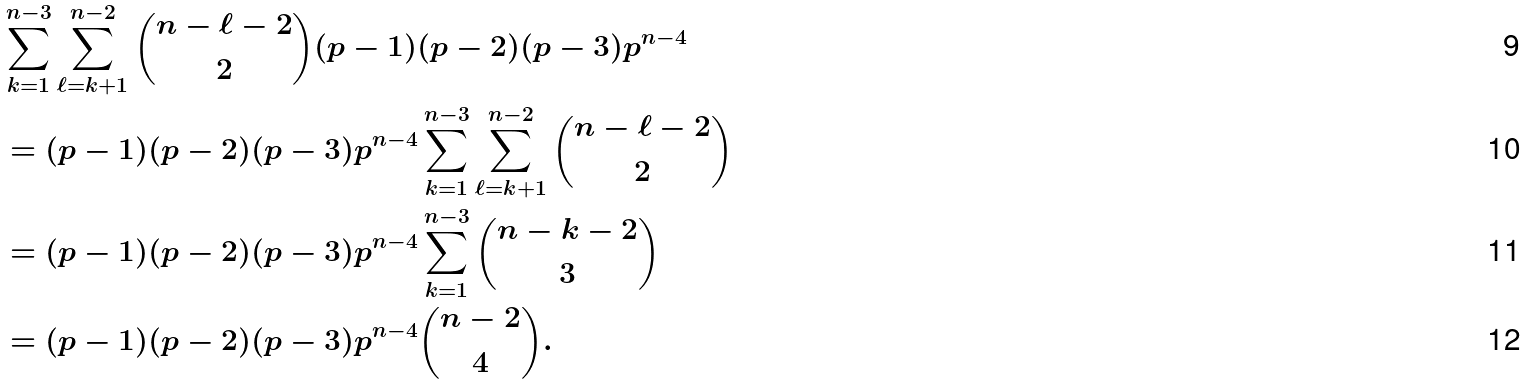Convert formula to latex. <formula><loc_0><loc_0><loc_500><loc_500>& \sum _ { k = 1 } ^ { n - 3 } \sum _ { \ell = k + 1 } ^ { n - 2 } \binom { n - \ell - 2 } { 2 } ( p - 1 ) ( p - 2 ) ( p - 3 ) p ^ { n - 4 } \\ & = ( p - 1 ) ( p - 2 ) ( p - 3 ) p ^ { n - 4 } \sum _ { k = 1 } ^ { n - 3 } \sum _ { \ell = k + 1 } ^ { n - 2 } \binom { n - \ell - 2 } { 2 } \\ & = ( p - 1 ) ( p - 2 ) ( p - 3 ) p ^ { n - 4 } \sum _ { k = 1 } ^ { n - 3 } \binom { n - k - 2 } { 3 } \\ & = ( p - 1 ) ( p - 2 ) ( p - 3 ) p ^ { n - 4 } \binom { n - 2 } { 4 } .</formula> 